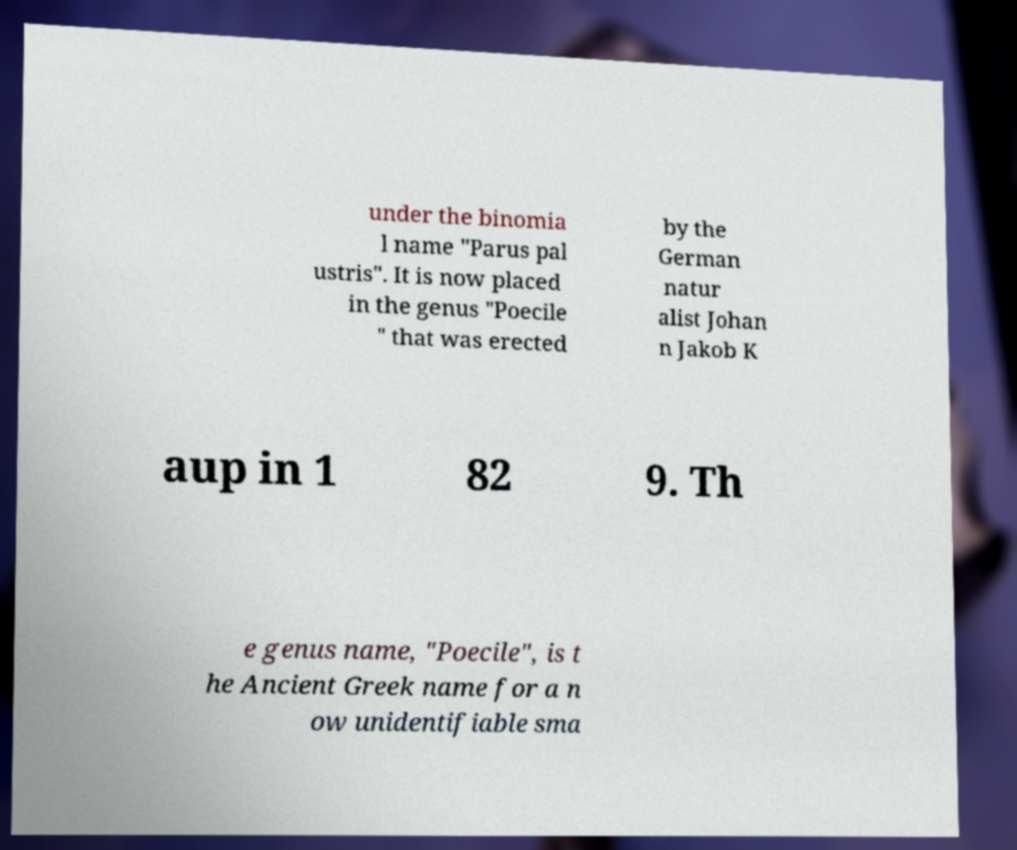Could you extract and type out the text from this image? under the binomia l name "Parus pal ustris". It is now placed in the genus "Poecile " that was erected by the German natur alist Johan n Jakob K aup in 1 82 9. Th e genus name, "Poecile", is t he Ancient Greek name for a n ow unidentifiable sma 